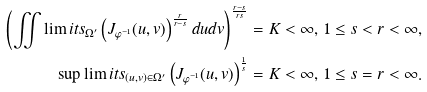<formula> <loc_0><loc_0><loc_500><loc_500>\left ( \iint \lim i t s _ { \Omega ^ { \prime } } \left ( J _ { \varphi ^ { - 1 } } ( u , v ) \right ) ^ { \frac { r } { r - s } } d u d v \right ) ^ { \frac { r - s } { r s } } = K < \infty , \, 1 \leq s < r < \infty , \\ \sup \lim i t s _ { ( u , v ) \in \Omega ^ { \prime } } \left ( J _ { \varphi ^ { - 1 } } ( u , v ) \right ) ^ { \frac { 1 } { s } } = K < \infty , \, 1 \leq s = r < \infty .</formula> 